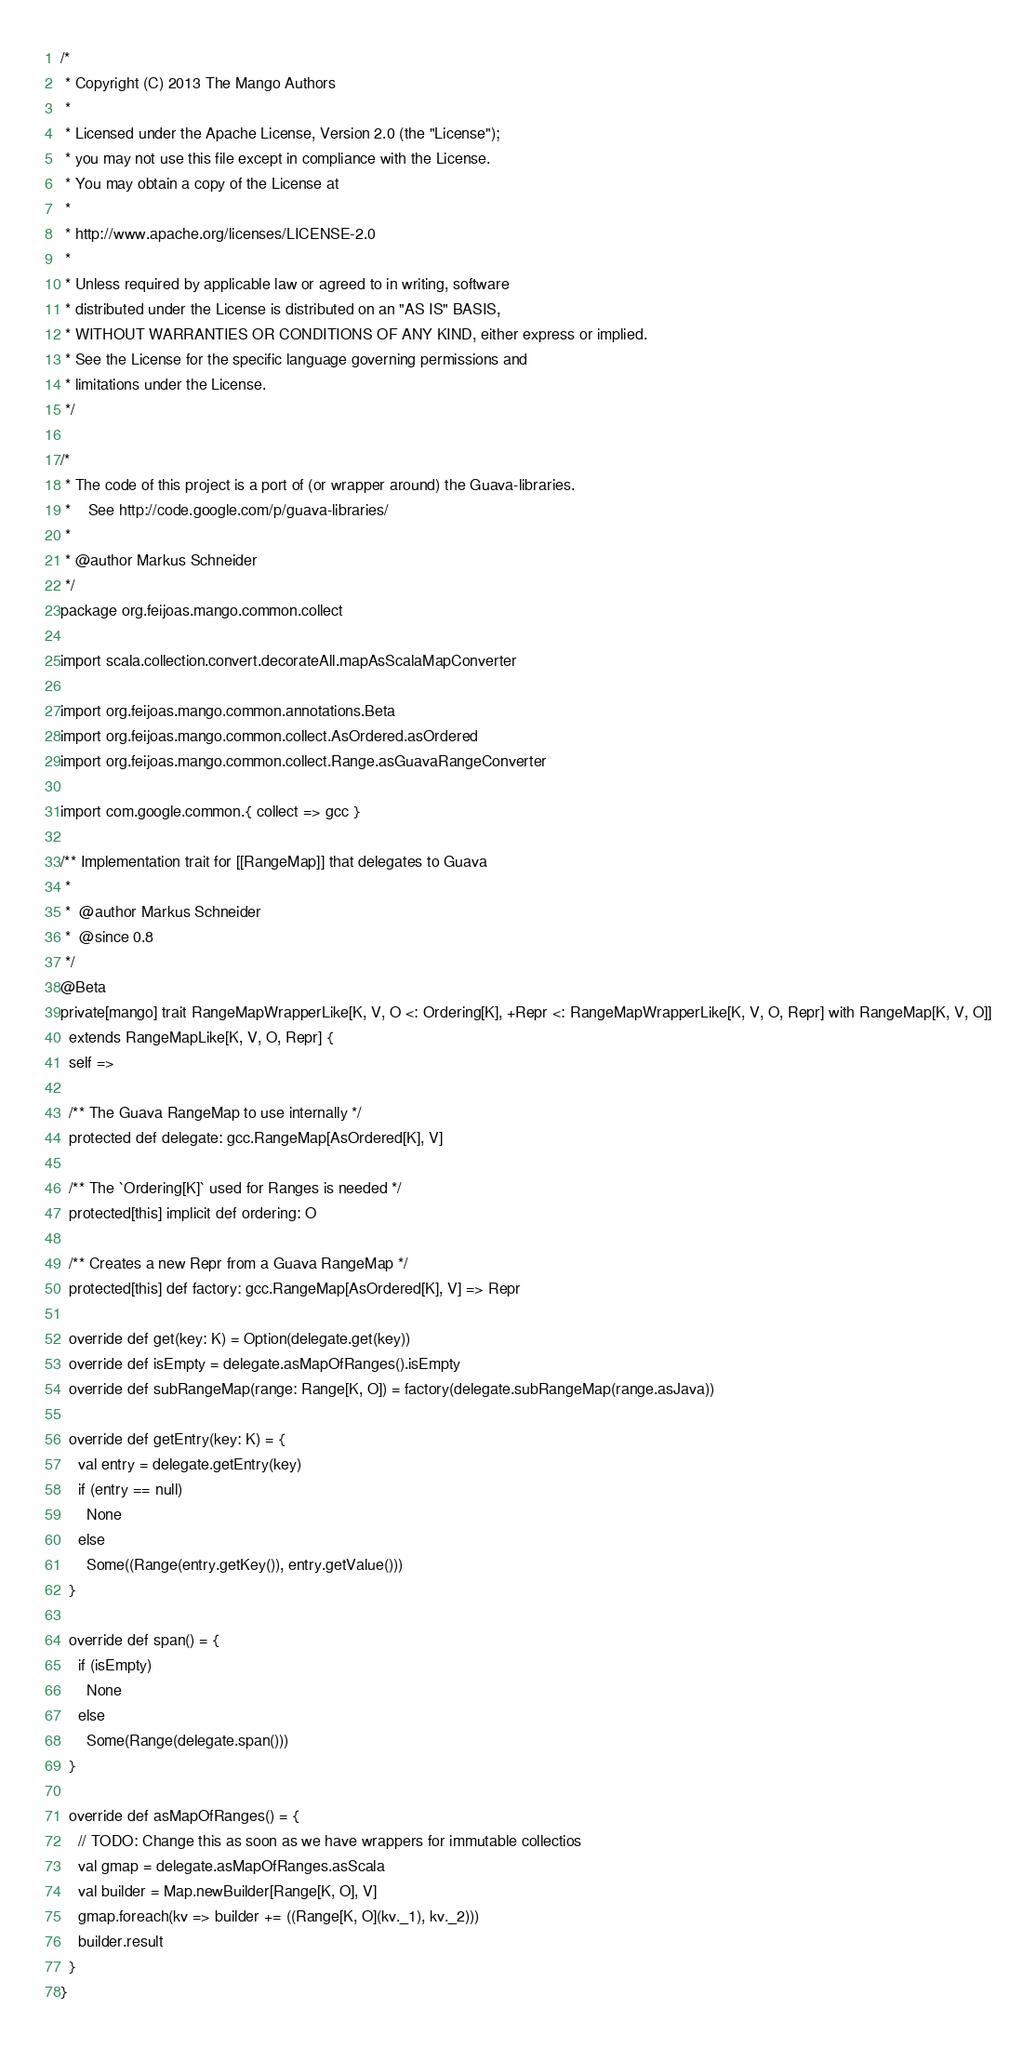<code> <loc_0><loc_0><loc_500><loc_500><_Scala_>/*
 * Copyright (C) 2013 The Mango Authors
 *
 * Licensed under the Apache License, Version 2.0 (the "License");
 * you may not use this file except in compliance with the License.
 * You may obtain a copy of the License at
 *
 * http://www.apache.org/licenses/LICENSE-2.0
 *
 * Unless required by applicable law or agreed to in writing, software
 * distributed under the License is distributed on an "AS IS" BASIS,
 * WITHOUT WARRANTIES OR CONDITIONS OF ANY KIND, either express or implied.
 * See the License for the specific language governing permissions and
 * limitations under the License.
 */

/*
 * The code of this project is a port of (or wrapper around) the Guava-libraries.
 *    See http://code.google.com/p/guava-libraries/
 *
 * @author Markus Schneider
 */
package org.feijoas.mango.common.collect

import scala.collection.convert.decorateAll.mapAsScalaMapConverter

import org.feijoas.mango.common.annotations.Beta
import org.feijoas.mango.common.collect.AsOrdered.asOrdered
import org.feijoas.mango.common.collect.Range.asGuavaRangeConverter

import com.google.common.{ collect => gcc }

/** Implementation trait for [[RangeMap]] that delegates to Guava
 *
 *  @author Markus Schneider
 *  @since 0.8
 */
@Beta
private[mango] trait RangeMapWrapperLike[K, V, O <: Ordering[K], +Repr <: RangeMapWrapperLike[K, V, O, Repr] with RangeMap[K, V, O]]
  extends RangeMapLike[K, V, O, Repr] {
  self =>

  /** The Guava RangeMap to use internally */
  protected def delegate: gcc.RangeMap[AsOrdered[K], V]

  /** The `Ordering[K]` used for Ranges is needed */
  protected[this] implicit def ordering: O

  /** Creates a new Repr from a Guava RangeMap */
  protected[this] def factory: gcc.RangeMap[AsOrdered[K], V] => Repr

  override def get(key: K) = Option(delegate.get(key))
  override def isEmpty = delegate.asMapOfRanges().isEmpty
  override def subRangeMap(range: Range[K, O]) = factory(delegate.subRangeMap(range.asJava))

  override def getEntry(key: K) = {
    val entry = delegate.getEntry(key)
    if (entry == null)
      None
    else
      Some((Range(entry.getKey()), entry.getValue()))
  }

  override def span() = {
    if (isEmpty)
      None
    else
      Some(Range(delegate.span()))
  }

  override def asMapOfRanges() = {
    // TODO: Change this as soon as we have wrappers for immutable collectios
    val gmap = delegate.asMapOfRanges.asScala
    val builder = Map.newBuilder[Range[K, O], V]
    gmap.foreach(kv => builder += ((Range[K, O](kv._1), kv._2)))
    builder.result
  }
}</code> 